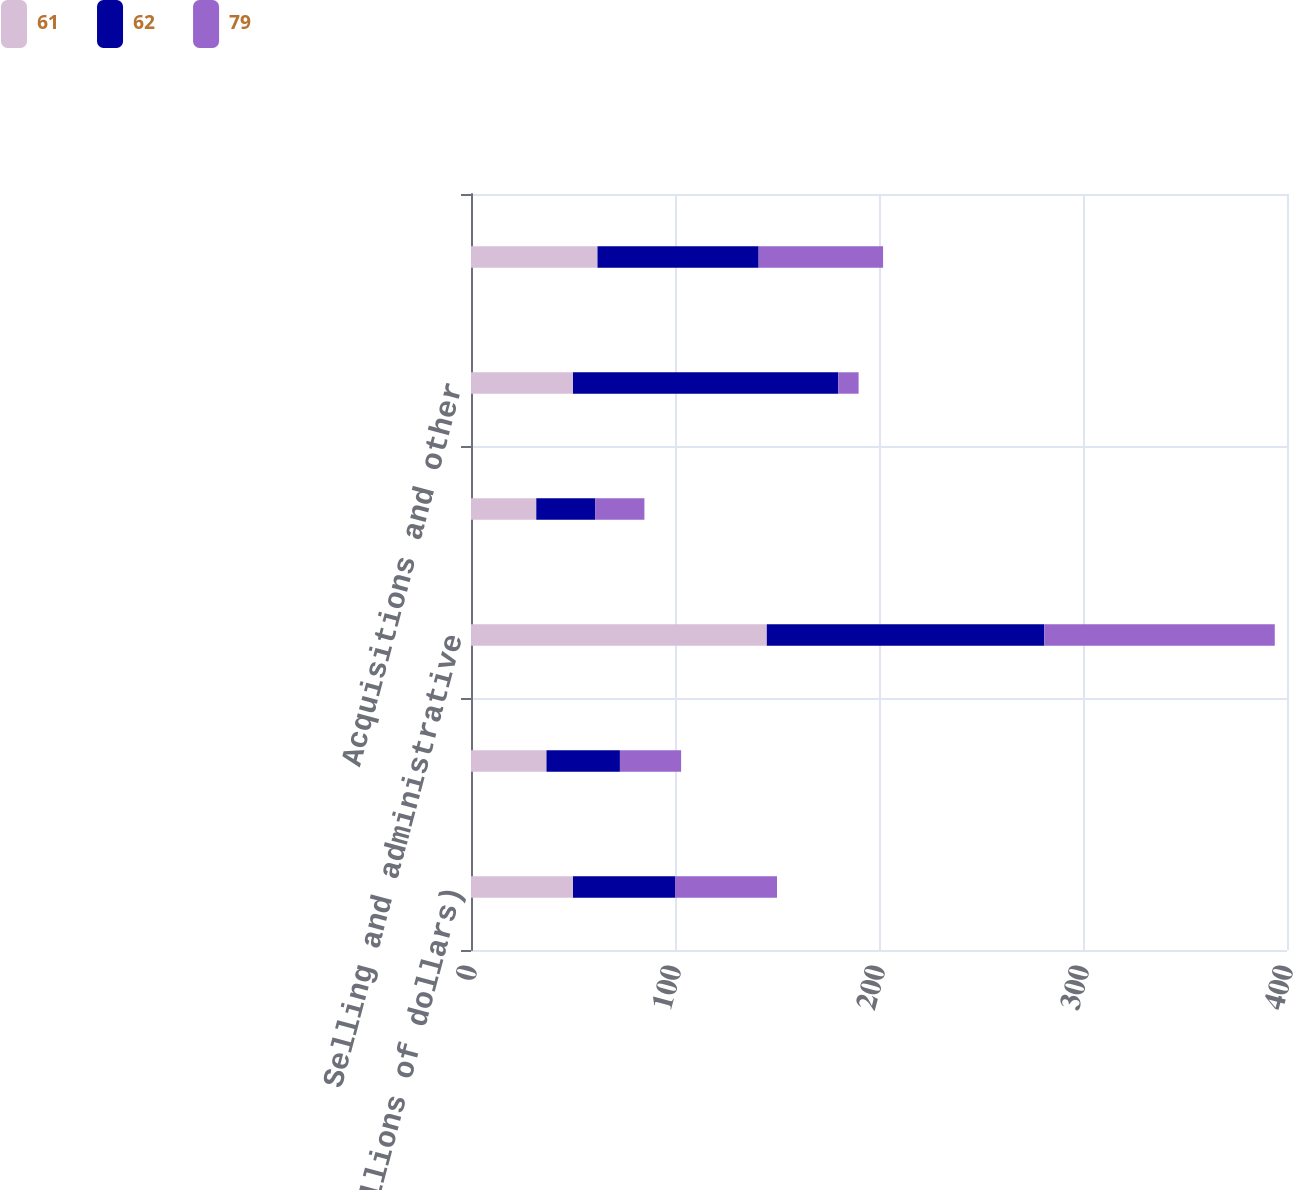Convert chart to OTSL. <chart><loc_0><loc_0><loc_500><loc_500><stacked_bar_chart><ecel><fcel>(Millions of dollars)<fcel>Cost of products sold<fcel>Selling and administrative<fcel>Research and development<fcel>Acquisitions and other<fcel>Tax benefit associated with<nl><fcel>61<fcel>50<fcel>37<fcel>145<fcel>32<fcel>50<fcel>62<nl><fcel>62<fcel>50<fcel>36<fcel>136<fcel>29<fcel>130<fcel>79<nl><fcel>79<fcel>50<fcel>30<fcel>113<fcel>24<fcel>10<fcel>61<nl></chart> 